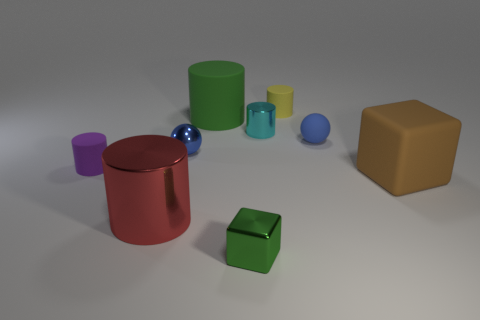Add 1 small yellow cylinders. How many objects exist? 10 Subtract all big red cylinders. How many cylinders are left? 4 Subtract all balls. How many objects are left? 7 Subtract all brown cubes. How many cubes are left? 1 Subtract all tiny spheres. Subtract all small blue balls. How many objects are left? 5 Add 7 tiny rubber balls. How many tiny rubber balls are left? 8 Add 4 purple blocks. How many purple blocks exist? 4 Subtract 0 blue cubes. How many objects are left? 9 Subtract 1 cylinders. How many cylinders are left? 4 Subtract all green blocks. Subtract all gray cylinders. How many blocks are left? 1 